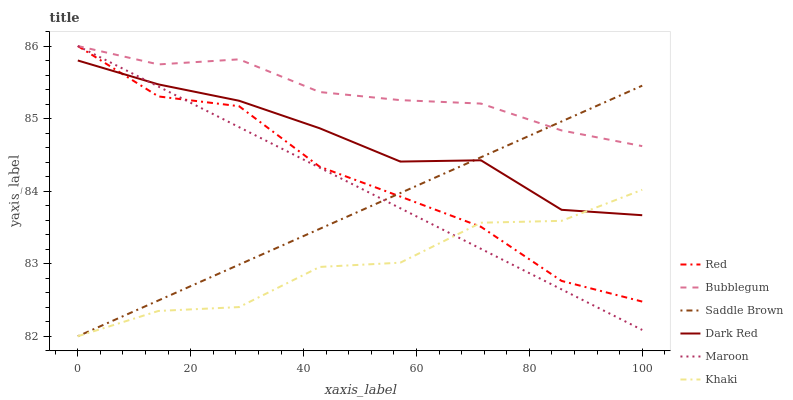Does Khaki have the minimum area under the curve?
Answer yes or no. Yes. Does Bubblegum have the maximum area under the curve?
Answer yes or no. Yes. Does Dark Red have the minimum area under the curve?
Answer yes or no. No. Does Dark Red have the maximum area under the curve?
Answer yes or no. No. Is Saddle Brown the smoothest?
Answer yes or no. Yes. Is Khaki the roughest?
Answer yes or no. Yes. Is Dark Red the smoothest?
Answer yes or no. No. Is Dark Red the roughest?
Answer yes or no. No. Does Khaki have the lowest value?
Answer yes or no. Yes. Does Dark Red have the lowest value?
Answer yes or no. No. Does Red have the highest value?
Answer yes or no. Yes. Does Dark Red have the highest value?
Answer yes or no. No. Is Khaki less than Bubblegum?
Answer yes or no. Yes. Is Bubblegum greater than Khaki?
Answer yes or no. Yes. Does Khaki intersect Maroon?
Answer yes or no. Yes. Is Khaki less than Maroon?
Answer yes or no. No. Is Khaki greater than Maroon?
Answer yes or no. No. Does Khaki intersect Bubblegum?
Answer yes or no. No. 